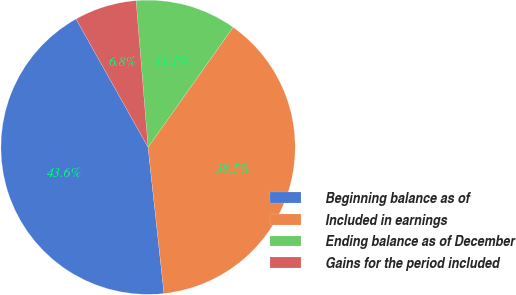Convert chart. <chart><loc_0><loc_0><loc_500><loc_500><pie_chart><fcel>Beginning balance as of<fcel>Included in earnings<fcel>Ending balance as of December<fcel>Gains for the period included<nl><fcel>43.59%<fcel>38.46%<fcel>11.11%<fcel>6.84%<nl></chart> 